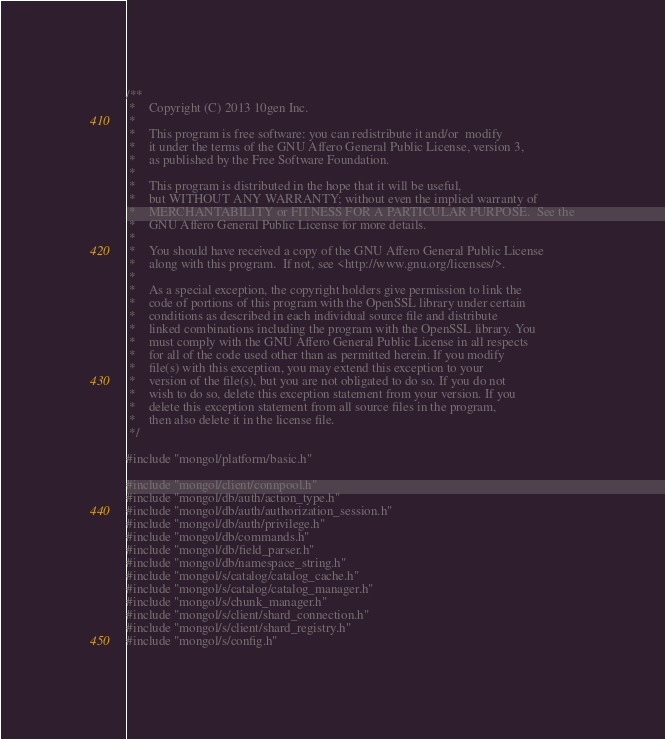<code> <loc_0><loc_0><loc_500><loc_500><_C++_>/**
 *    Copyright (C) 2013 10gen Inc.
 *
 *    This program is free software: you can redistribute it and/or  modify
 *    it under the terms of the GNU Affero General Public License, version 3,
 *    as published by the Free Software Foundation.
 *
 *    This program is distributed in the hope that it will be useful,
 *    but WITHOUT ANY WARRANTY; without even the implied warranty of
 *    MERCHANTABILITY or FITNESS FOR A PARTICULAR PURPOSE.  See the
 *    GNU Affero General Public License for more details.
 *
 *    You should have received a copy of the GNU Affero General Public License
 *    along with this program.  If not, see <http://www.gnu.org/licenses/>.
 *
 *    As a special exception, the copyright holders give permission to link the
 *    code of portions of this program with the OpenSSL library under certain
 *    conditions as described in each individual source file and distribute
 *    linked combinations including the program with the OpenSSL library. You
 *    must comply with the GNU Affero General Public License in all respects
 *    for all of the code used other than as permitted herein. If you modify
 *    file(s) with this exception, you may extend this exception to your
 *    version of the file(s), but you are not obligated to do so. If you do not
 *    wish to do so, delete this exception statement from your version. If you
 *    delete this exception statement from all source files in the program,
 *    then also delete it in the license file.
 */

#include "mongol/platform/basic.h"

#include "mongol/client/connpool.h"
#include "mongol/db/auth/action_type.h"
#include "mongol/db/auth/authorization_session.h"
#include "mongol/db/auth/privilege.h"
#include "mongol/db/commands.h"
#include "mongol/db/field_parser.h"
#include "mongol/db/namespace_string.h"
#include "mongol/s/catalog/catalog_cache.h"
#include "mongol/s/catalog/catalog_manager.h"
#include "mongol/s/chunk_manager.h"
#include "mongol/s/client/shard_connection.h"
#include "mongol/s/client/shard_registry.h"
#include "mongol/s/config.h"</code> 